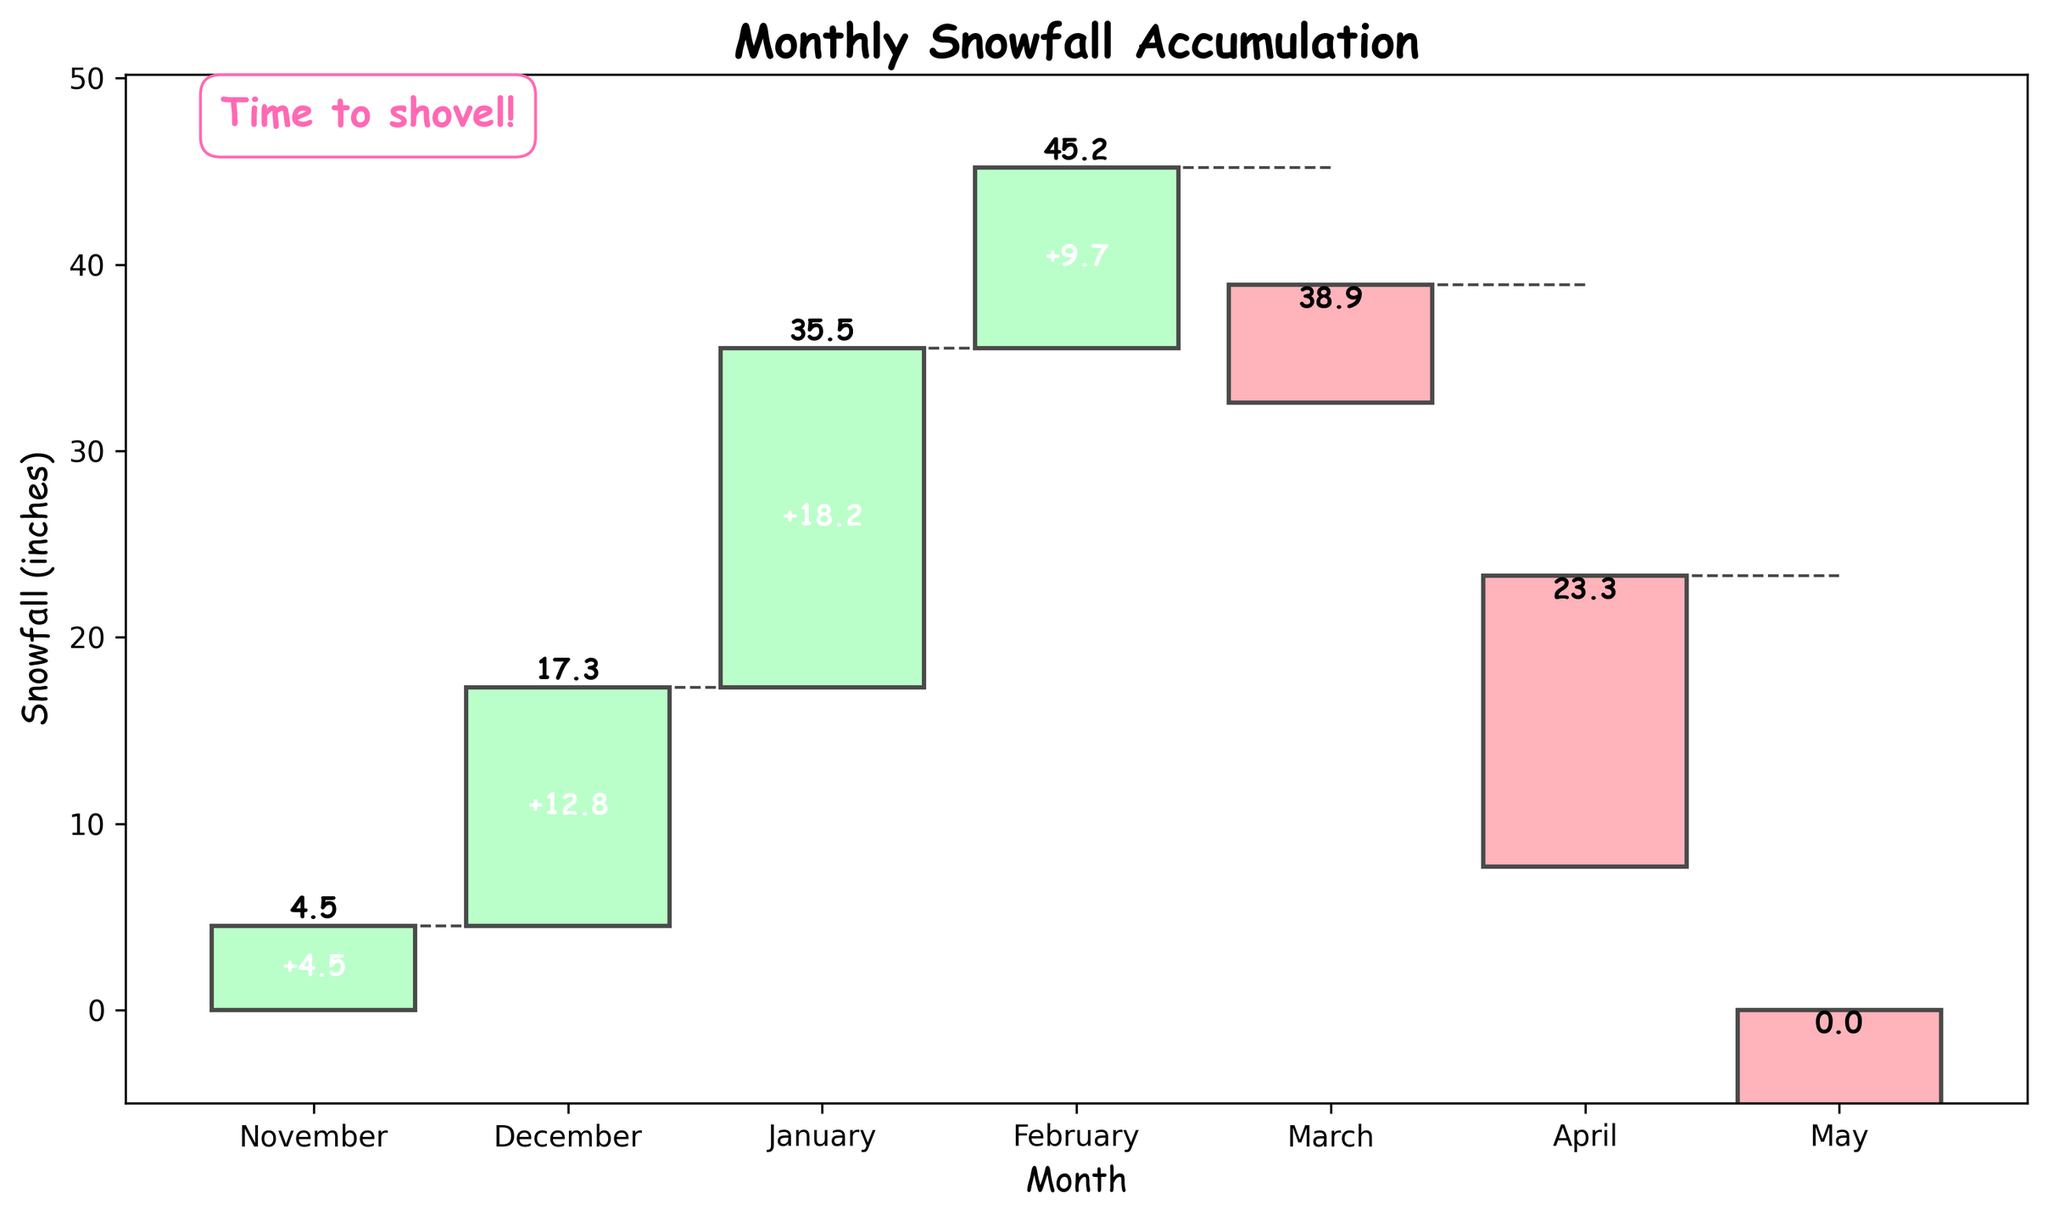What's the title of the chart? The title of the chart is located at the top of the figure.
Answer: Monthly Snowfall Accumulation Which month has the highest snowfall accumulation? To answer this, look at the bars representing each month's snowfall change and identify the month with the highest positive value.
Answer: January How much did the snowfall decrease in March? Check the March bar and see the decrease value, which is represented in a red color.
Answer: 6.3 inches What was the total snowfall by the end of February? Refer to the running total value at the end of February on the Y-axis.
Answer: 45.2 inches Which two months had the largest snowfall decrease? Look for the months with the largest negative values (red bars) and list them.
Answer: April and May How much snowfall was accumulated by the end of January? Look at the running total label for January on the Y-axis.
Answer: 35.5 inches What is the color coding for the increase and decrease in snowfall? Observe the colors used for the bars indicating monthly changes.
Answer: Increases are green, and decreases are red What is the total decrease in snowfall from March to May? Add up the decrease values for March (-6.3), April (-15.6), and May (-23.3). The sum is 6.3 + 15.6 + 23.3 = 45.2
Answer: 45.2 inches Which month had a smaller decrease in snowfall, March or April? Compare the negative value bars for both March and April.
Answer: March How much snowfall was gained from November to the end of February? Add the increases from November (4.5), December (12.8), January (18.2), and February (9.7). The sum is 4.5 + 12.8 + 18.2 + 9.7 = 45.2
Answer: 45.2 inches 